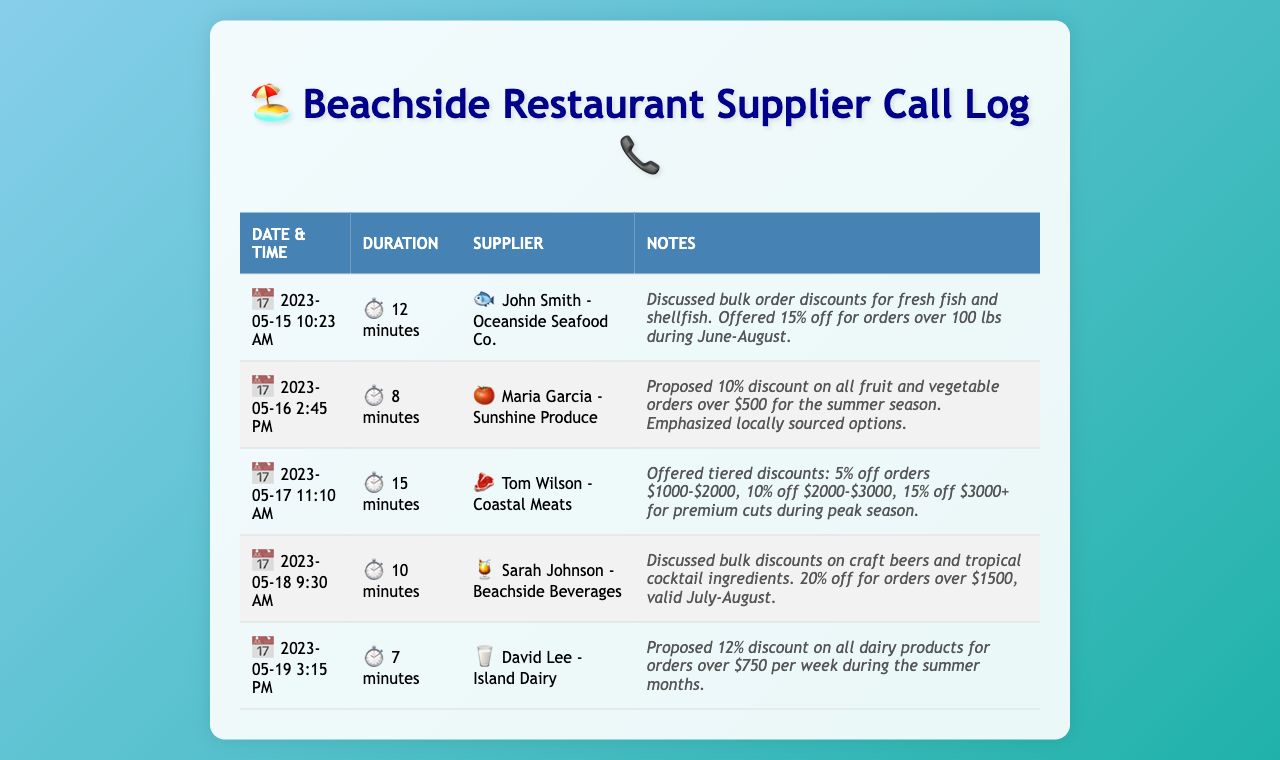What supplier offered a bulk discount on fresh fish? John Smith from Oceanside Seafood Co. offered a discount on fresh fish and shellfish during a call.
Answer: John Smith What was the discount percentage for orders over $500 from Sunshine Produce? The discount proposed by Maria Garcia was 10% for orders over $500.
Answer: 10% Which supplier discussed discounts on craft beers? Sarah Johnson from Beachside Beverages discussed bulk discounts on craft beers and cocktail ingredients.
Answer: Sarah Johnson What is the duration of the call with Coastal Meats? The call with Tom Wilson lasted 15 minutes, which is noted in the document.
Answer: 15 minutes What tiered discounts did Coastal Meats offer? The document states the tiered discounts as 5%, 10%, and 15% based on order amounts.
Answer: 5%, 10%, 15% During which months did Oceanside Seafood Co. offer discounts? The discounts for fresh fish and shellfish were offered for June through August.
Answer: June-August How much was the minimum order value to receive the 12% discount from Island Dairy? David Lee proposed a minimum order value of $750 per week to receive the 12% discount.
Answer: $750 What was the total duration of all calls listed in the document? The total durations of the calls can be calculated as 12+8+15+10+7 minutes, but this requires summation.
Answer: 52 minutes What is the main purpose of the document? The document records telephone calls with suppliers discussing bulk order discounts for the restaurant.
Answer: Call log for bulk order discounts 